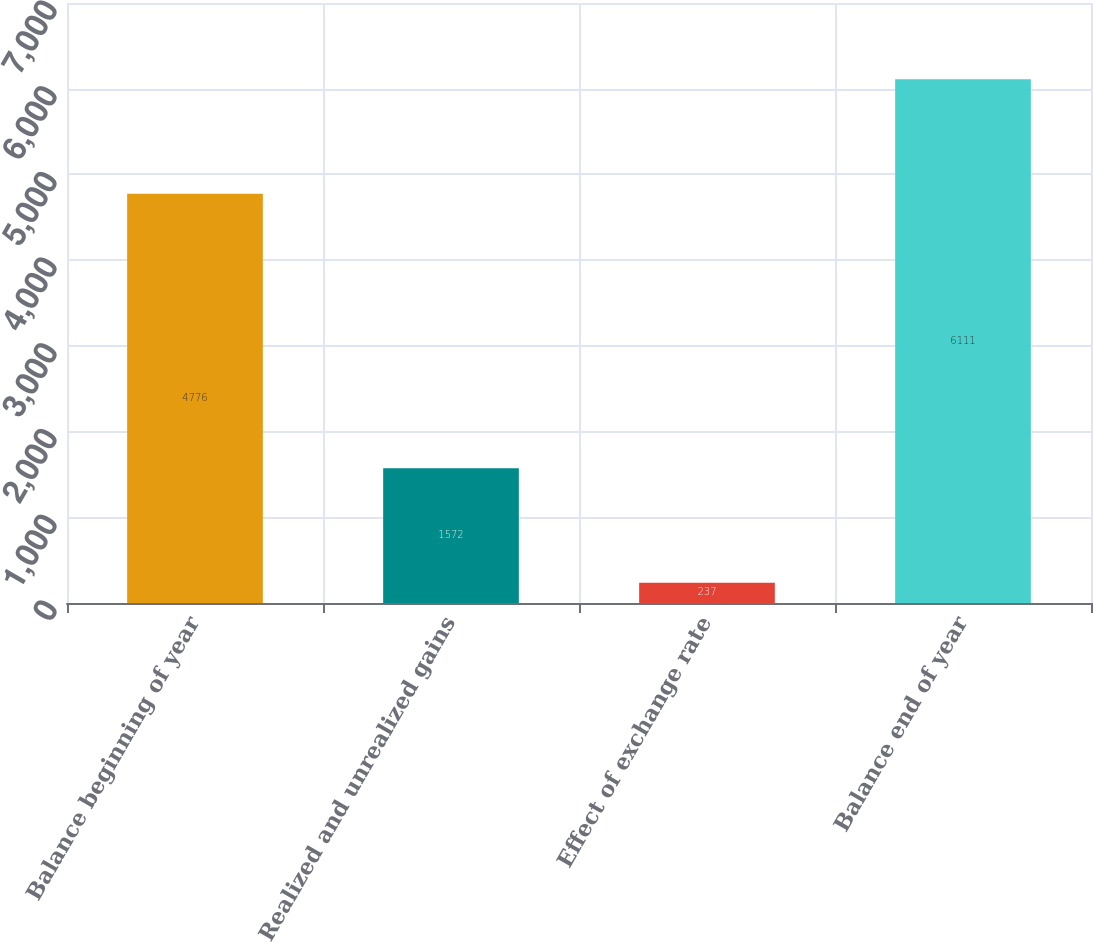Convert chart. <chart><loc_0><loc_0><loc_500><loc_500><bar_chart><fcel>Balance beginning of year<fcel>Realized and unrealized gains<fcel>Effect of exchange rate<fcel>Balance end of year<nl><fcel>4776<fcel>1572<fcel>237<fcel>6111<nl></chart> 